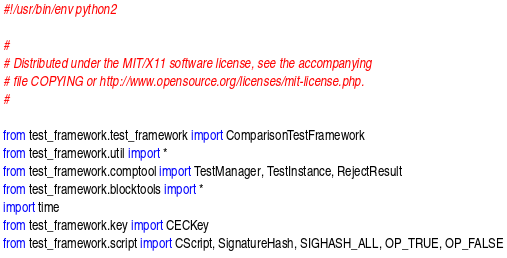Convert code to text. <code><loc_0><loc_0><loc_500><loc_500><_Python_>#!/usr/bin/env python2

#
# Distributed under the MIT/X11 software license, see the accompanying
# file COPYING or http://www.opensource.org/licenses/mit-license.php.
#

from test_framework.test_framework import ComparisonTestFramework
from test_framework.util import *
from test_framework.comptool import TestManager, TestInstance, RejectResult
from test_framework.blocktools import *
import time
from test_framework.key import CECKey
from test_framework.script import CScript, SignatureHash, SIGHASH_ALL, OP_TRUE, OP_FALSE
</code> 